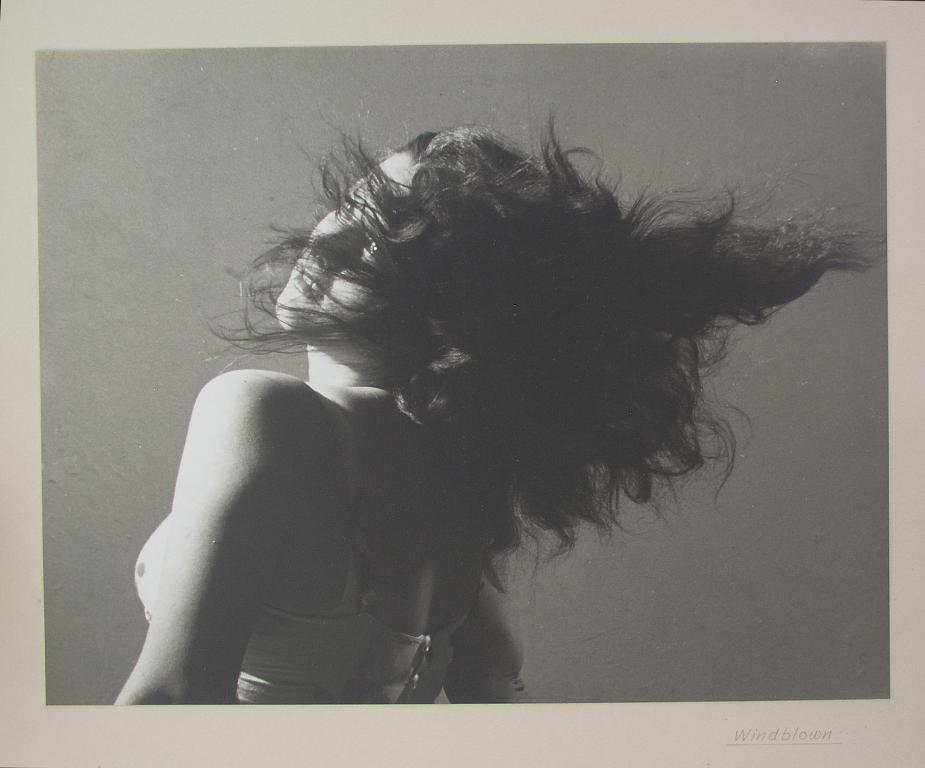Please provide a concise description of this image. In this picture I can see there is a woman standing she is looking at right side and this is a black and white picture and there is a frame around the photograph. There is a watermark. 